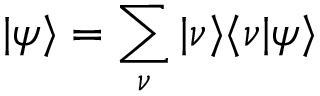<formula> <loc_0><loc_0><loc_500><loc_500>| \psi \rangle = \sum _ { \nu } | \nu \rangle \langle \nu | \psi \rangle</formula> 